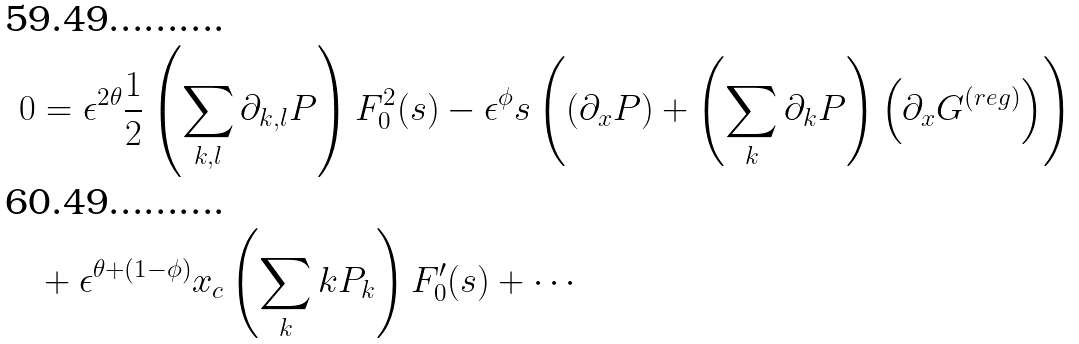Convert formula to latex. <formula><loc_0><loc_0><loc_500><loc_500>0 & = \epsilon ^ { 2 \theta } \frac { 1 } { 2 } \left ( \sum _ { k , l } \partial _ { k , l } P \right ) F _ { 0 } ^ { 2 } ( s ) - \epsilon ^ { \phi } s \left ( \left ( \partial _ { x } P \right ) + \left ( \sum _ { k } \partial _ { k } P \right ) \left ( \partial _ { x } G ^ { ( r e g ) } \right ) \right ) \\ & + \epsilon ^ { \theta + ( 1 - \phi ) } x _ { c } \left ( \sum _ { k } k P _ { k } \right ) F _ { 0 } ^ { \prime } ( s ) + \cdots</formula> 